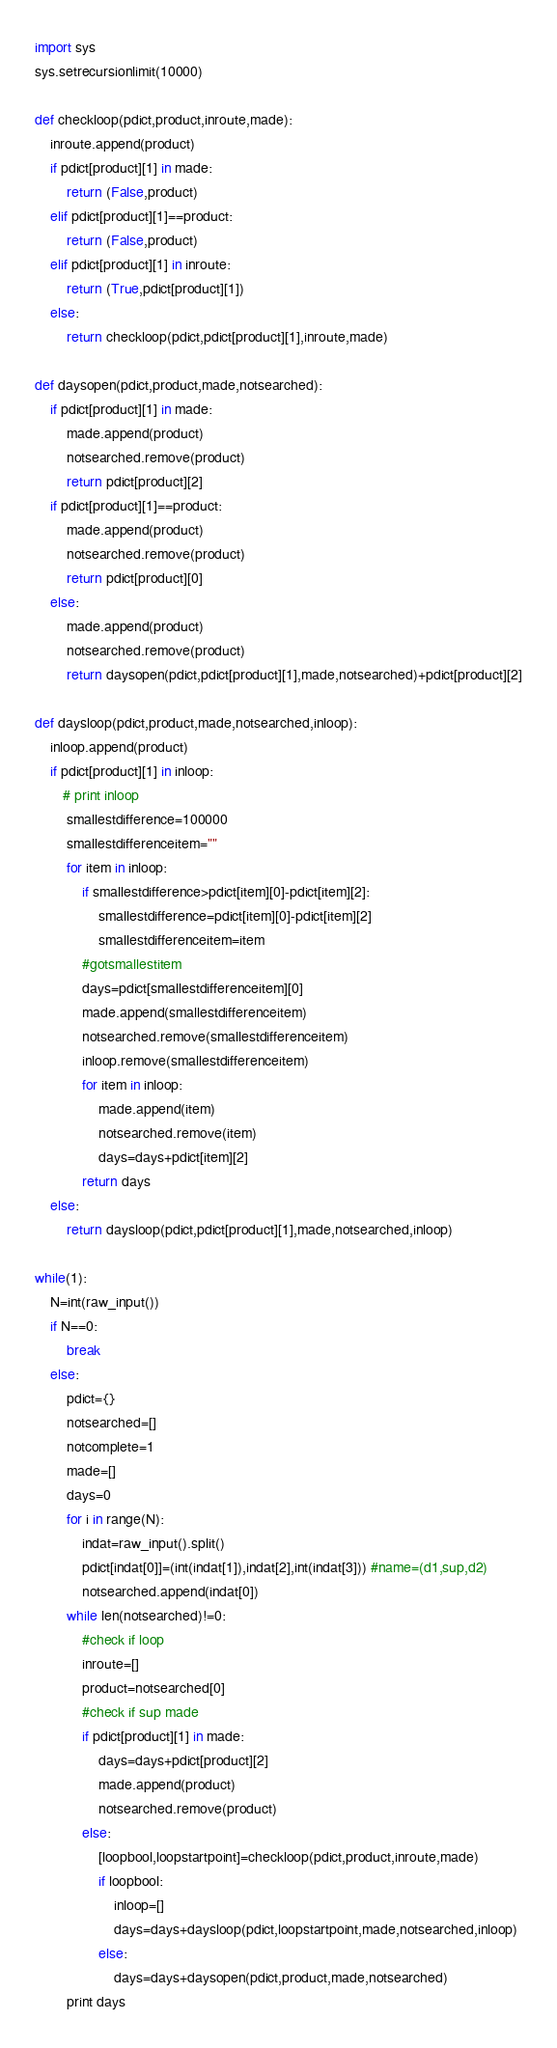<code> <loc_0><loc_0><loc_500><loc_500><_Python_>import sys
sys.setrecursionlimit(10000) 

def checkloop(pdict,product,inroute,made):
    inroute.append(product)
    if pdict[product][1] in made:
        return (False,product)
    elif pdict[product][1]==product:
        return (False,product)
    elif pdict[product][1] in inroute:
        return (True,pdict[product][1])
    else:
        return checkloop(pdict,pdict[product][1],inroute,made)

def daysopen(pdict,product,made,notsearched):
    if pdict[product][1] in made:
        made.append(product)
        notsearched.remove(product)
        return pdict[product][2]
    if pdict[product][1]==product:
        made.append(product)
        notsearched.remove(product)
        return pdict[product][0]
    else:
        made.append(product)
        notsearched.remove(product)
        return daysopen(pdict,pdict[product][1],made,notsearched)+pdict[product][2]
    
def daysloop(pdict,product,made,notsearched,inloop):
    inloop.append(product)
    if pdict[product][1] in inloop:
       # print inloop
        smallestdifference=100000
        smallestdifferenceitem=""
        for item in inloop:
            if smallestdifference>pdict[item][0]-pdict[item][2]:
                smallestdifference=pdict[item][0]-pdict[item][2]
                smallestdifferenceitem=item
            #gotsmallestitem
            days=pdict[smallestdifferenceitem][0]
            made.append(smallestdifferenceitem)
            notsearched.remove(smallestdifferenceitem)
            inloop.remove(smallestdifferenceitem)
            for item in inloop:
                made.append(item)
                notsearched.remove(item)
                days=days+pdict[item][2]
            return days
    else:
        return daysloop(pdict,pdict[product][1],made,notsearched,inloop)
    
while(1):
    N=int(raw_input())
    if N==0:
        break
    else:
        pdict={}
        notsearched=[]
        notcomplete=1
        made=[]
        days=0
        for i in range(N):
            indat=raw_input().split()
            pdict[indat[0]]=(int(indat[1]),indat[2],int(indat[3])) #name=(d1,sup,d2)
            notsearched.append(indat[0])
        while len(notsearched)!=0:
            #check if loop
            inroute=[]
            product=notsearched[0]
            #check if sup made
            if pdict[product][1] in made:
                days=days+pdict[product][2]
                made.append(product)
                notsearched.remove(product)
            else:
                [loopbool,loopstartpoint]=checkloop(pdict,product,inroute,made)
                if loopbool:
                    inloop=[]
                    days=days+daysloop(pdict,loopstartpoint,made,notsearched,inloop)
                else:
                    days=days+daysopen(pdict,product,made,notsearched)
        print days</code> 